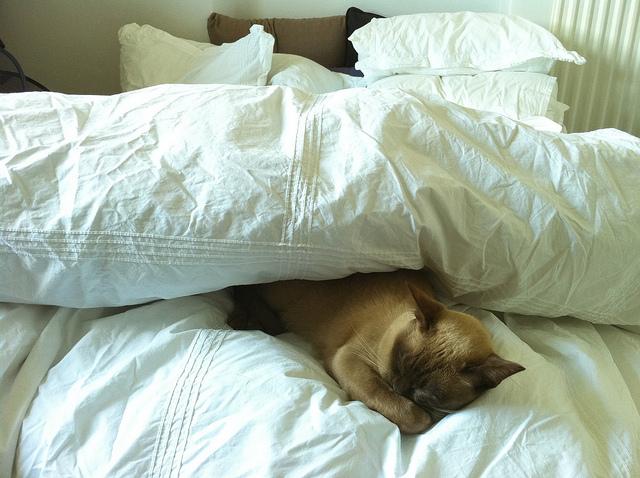What is sleeping in the bed covers?
Concise answer only. Cat. What pattern is on the cat's tail?
Be succinct. Stripes. What color are the covers?
Answer briefly. White. How many pillows are there?
Give a very brief answer. 4. 